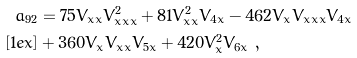Convert formula to latex. <formula><loc_0><loc_0><loc_500><loc_500>a _ { 9 2 } & = 7 5 V _ { x x } V _ { x x x } ^ { 2 } + 8 1 V _ { x x } ^ { 2 } V _ { 4 x } - 4 6 2 V _ { x } V _ { x x x } V _ { 4 x } \\ [ 1 e x ] & + 3 6 0 V _ { x } V _ { x x } V _ { 5 x } + 4 2 0 V _ { x } ^ { 2 } V _ { 6 x } \ ,</formula> 